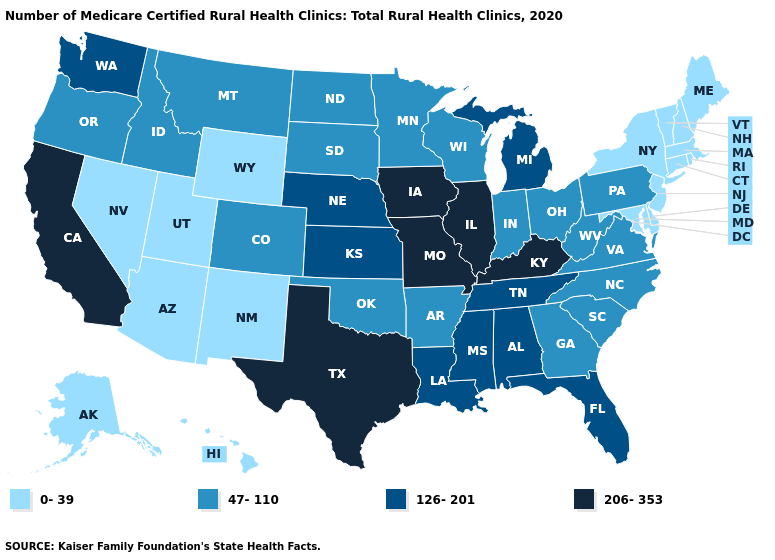Which states have the lowest value in the USA?
Be succinct. Alaska, Arizona, Connecticut, Delaware, Hawaii, Maine, Maryland, Massachusetts, Nevada, New Hampshire, New Jersey, New Mexico, New York, Rhode Island, Utah, Vermont, Wyoming. Among the states that border Virginia , which have the lowest value?
Keep it brief. Maryland. How many symbols are there in the legend?
Short answer required. 4. Is the legend a continuous bar?
Concise answer only. No. What is the value of California?
Give a very brief answer. 206-353. What is the lowest value in the Northeast?
Give a very brief answer. 0-39. Name the states that have a value in the range 206-353?
Give a very brief answer. California, Illinois, Iowa, Kentucky, Missouri, Texas. Which states have the highest value in the USA?
Be succinct. California, Illinois, Iowa, Kentucky, Missouri, Texas. Among the states that border Massachusetts , which have the lowest value?
Give a very brief answer. Connecticut, New Hampshire, New York, Rhode Island, Vermont. Which states hav the highest value in the MidWest?
Quick response, please. Illinois, Iowa, Missouri. Among the states that border New York , which have the highest value?
Be succinct. Pennsylvania. Which states hav the highest value in the West?
Write a very short answer. California. What is the value of Iowa?
Keep it brief. 206-353. What is the lowest value in states that border Arkansas?
Be succinct. 47-110. Among the states that border Louisiana , which have the highest value?
Quick response, please. Texas. 